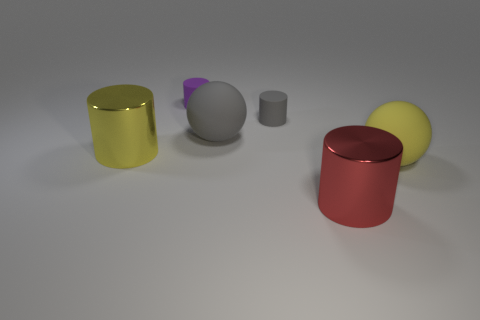The gray thing that is the same size as the red object is what shape?
Your answer should be very brief. Sphere. Is the red thing the same size as the purple thing?
Provide a succinct answer. No. What number of objects are either large brown rubber spheres or matte things left of the red cylinder?
Keep it short and to the point. 3. Is the number of tiny purple things that are to the right of the tiny gray cylinder less than the number of large red shiny objects that are left of the red metal object?
Offer a terse response. No. What number of other objects are the same material as the purple cylinder?
Offer a very short reply. 3. Are there any big yellow rubber objects in front of the shiny thing to the left of the purple cylinder?
Your response must be concise. Yes. What is the big thing that is both left of the big yellow rubber thing and in front of the large yellow shiny thing made of?
Keep it short and to the point. Metal. There is a small gray thing that is made of the same material as the tiny purple thing; what is its shape?
Ensure brevity in your answer.  Cylinder. Is there any other thing that has the same shape as the red object?
Your response must be concise. Yes. Do the big ball on the right side of the large red metallic cylinder and the small gray thing have the same material?
Provide a succinct answer. Yes. 